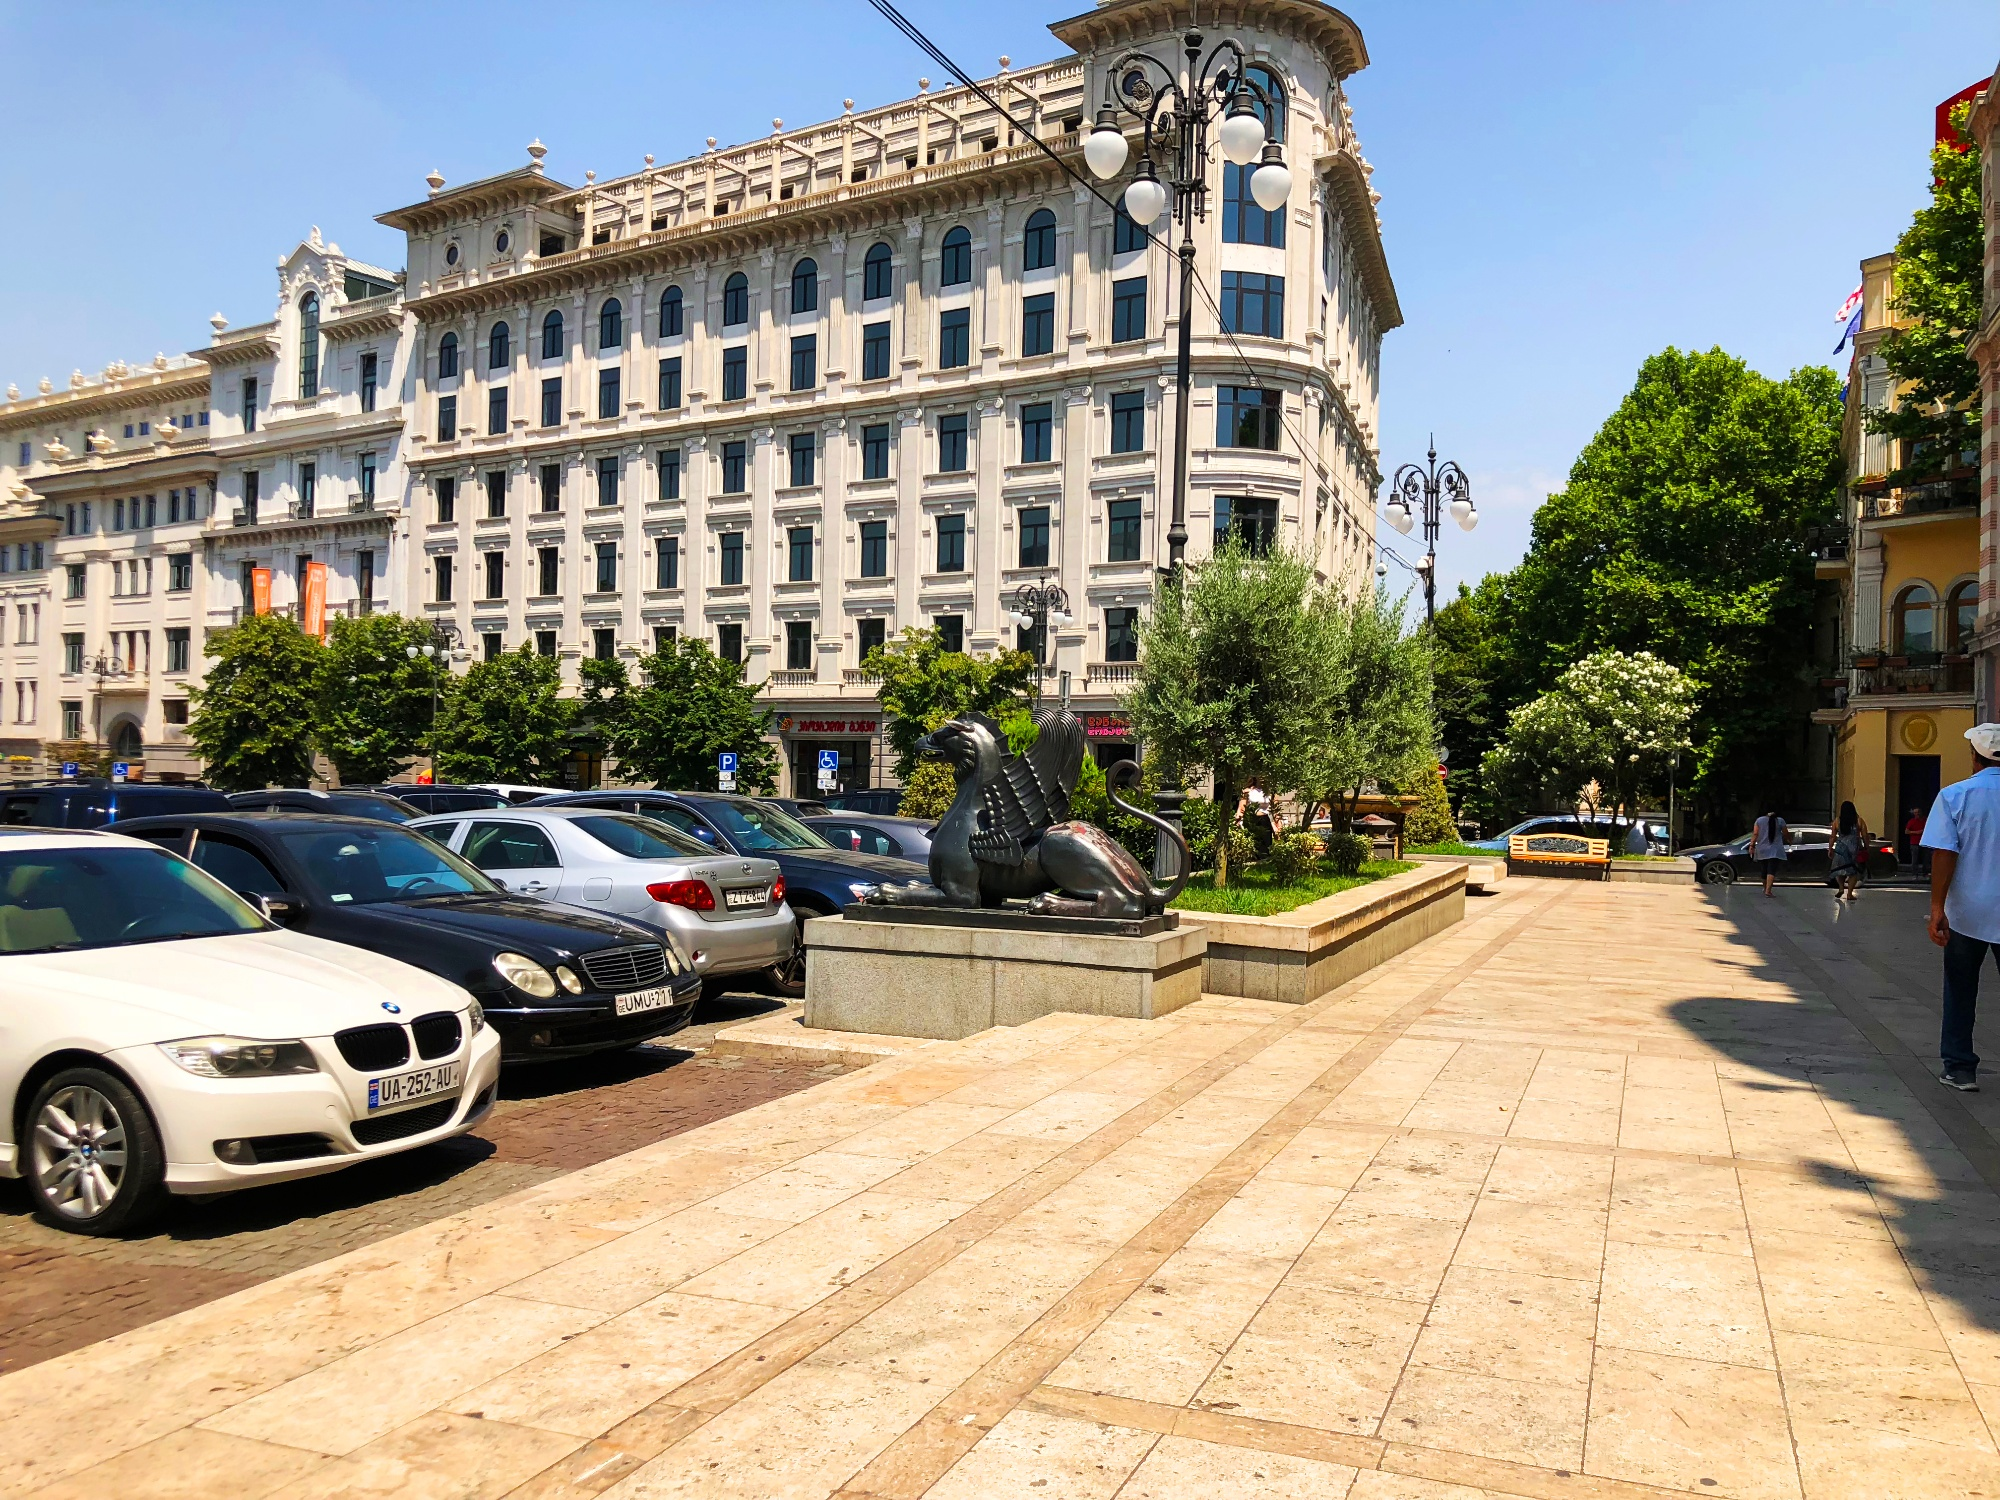Can you tell the time of day from the shadows and lighting in the image? Judging from the length and direction of the shadows cast by the trees and the statue, as well as the bright, unobscured sunlight, it seems to be midday. The sun appears to be high in the sky, indicating a time somewhere around noon, when the light is typically at its brightest and shadows are short. 